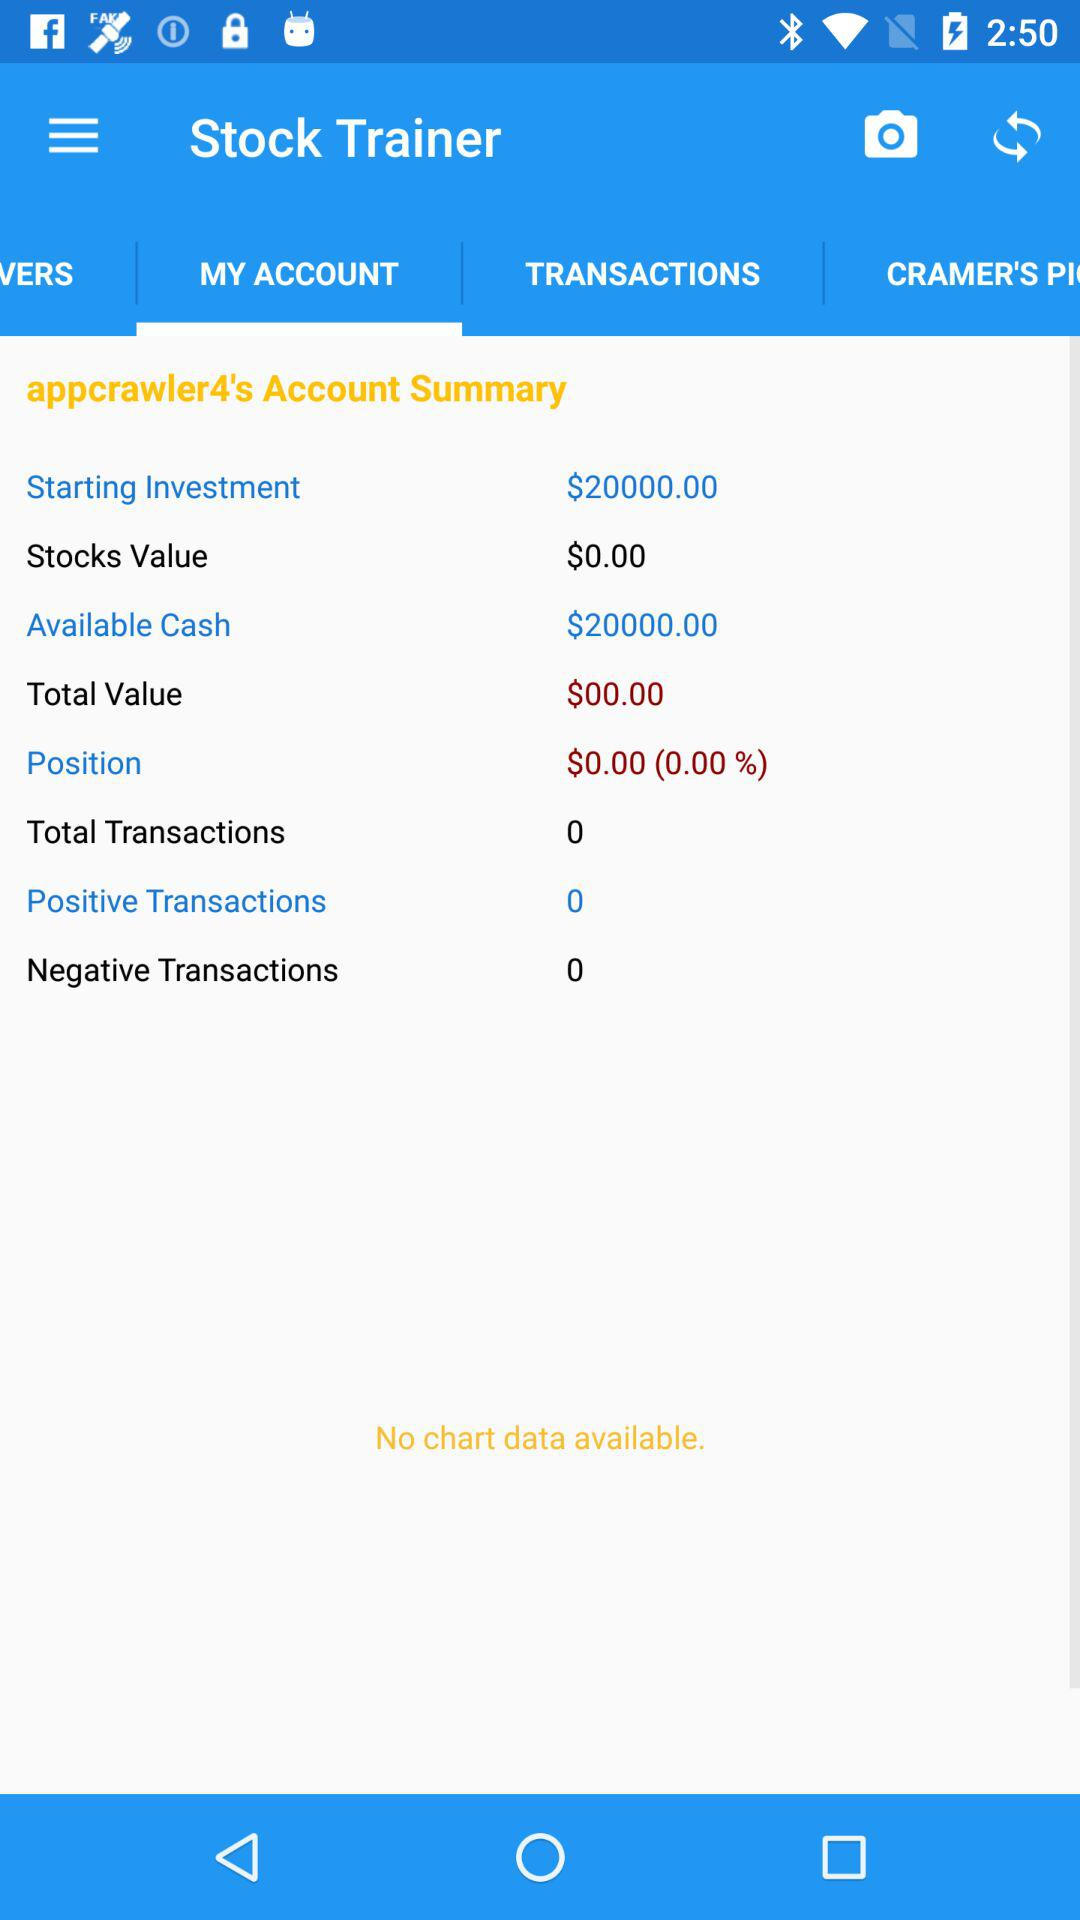How many transactions are there in total? There are 0 transactions in total. 